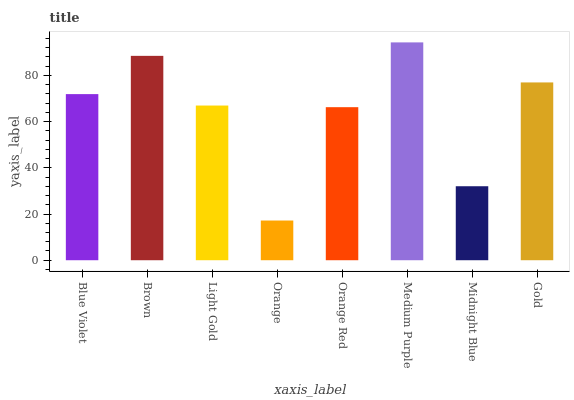Is Orange the minimum?
Answer yes or no. Yes. Is Medium Purple the maximum?
Answer yes or no. Yes. Is Brown the minimum?
Answer yes or no. No. Is Brown the maximum?
Answer yes or no. No. Is Brown greater than Blue Violet?
Answer yes or no. Yes. Is Blue Violet less than Brown?
Answer yes or no. Yes. Is Blue Violet greater than Brown?
Answer yes or no. No. Is Brown less than Blue Violet?
Answer yes or no. No. Is Blue Violet the high median?
Answer yes or no. Yes. Is Light Gold the low median?
Answer yes or no. Yes. Is Midnight Blue the high median?
Answer yes or no. No. Is Medium Purple the low median?
Answer yes or no. No. 